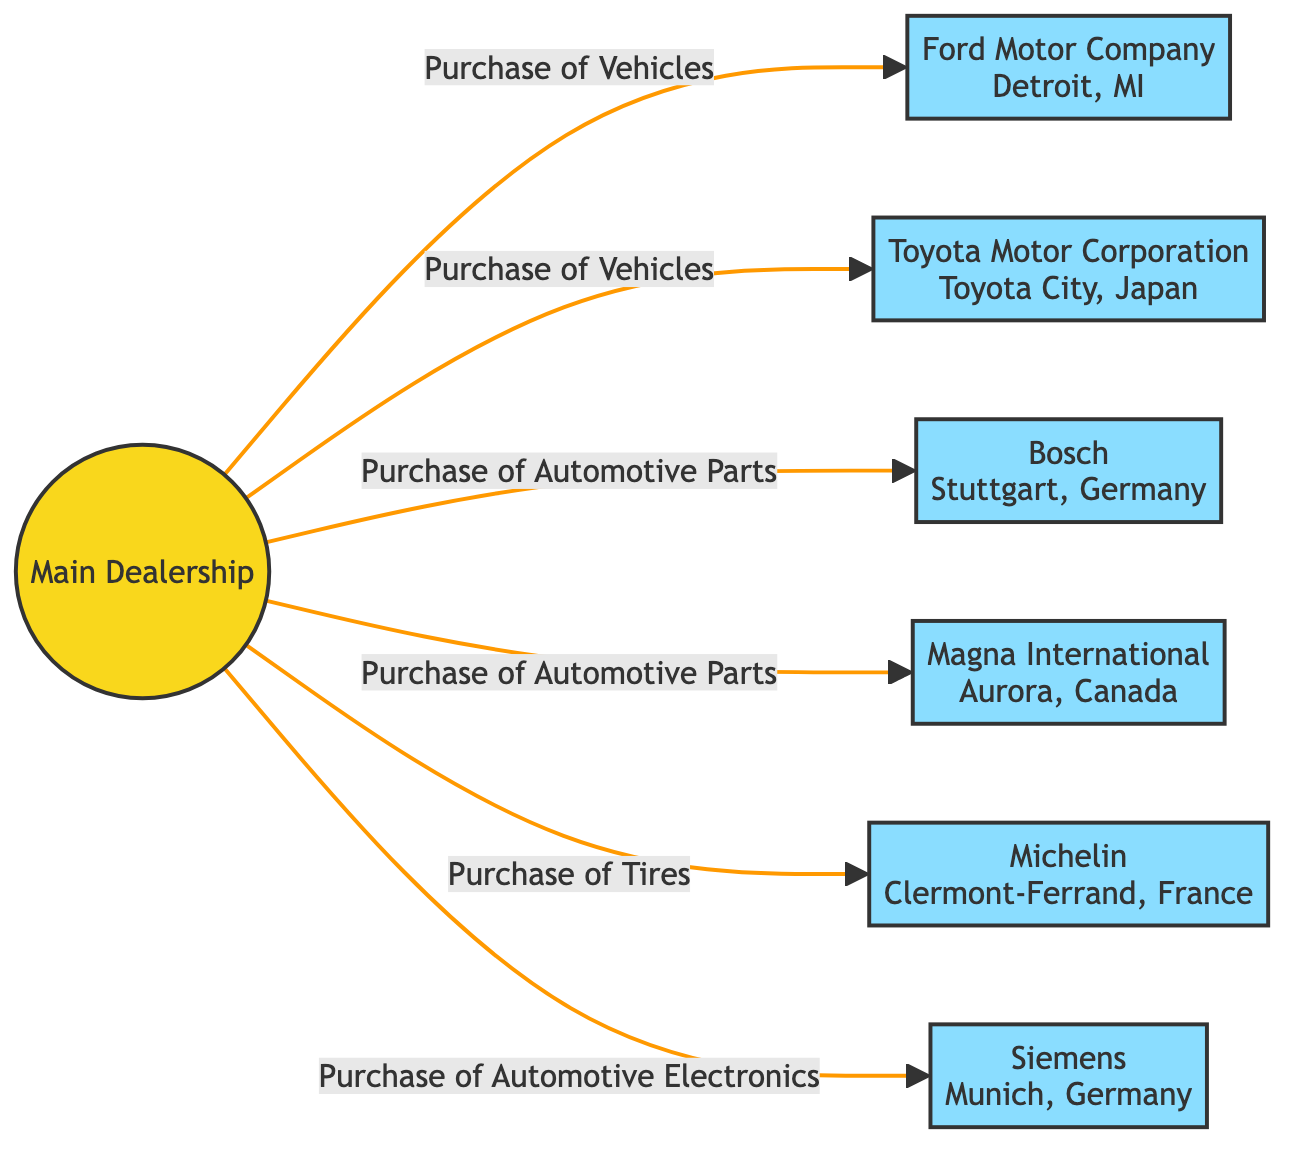What is the total number of suppliers shown in the diagram? The diagram lists six distinct suppliers connected to the main dealership. The suppliers are Ford Motor Company, Toyota Motor Corporation, Bosch, Magna International, Michelin, and Siemens.
Answer: 6 What relationship does the dealership have with Bosch? The relationship between the main dealership and Bosch is defined as "Purchase of Automotive Parts" according to the edges shown in the diagram.
Answer: Purchase of Automotive Parts Which supplier is located in Munich, Germany? The node designated as Siemens is listed in the diagram as being located in Munich, Germany.
Answer: Siemens How many different types of purchases does the dealership make? The dealership engages in three distinct types of purchases: vehicles from Ford and Toyota, automotive parts from Bosch and Magna, and tires from Michelin, plus automotive electronics from Siemens. This totals five unique purchase types.
Answer: 5 Which supplier has its headquarters in Clermont-Ferrand, France? The diagram shows Michelin as the supplier with its headquarters located in Clermont-Ferrand, France.
Answer: Michelin Which two suppliers offer vehicles to the dealership? The two suppliers that provide vehicles to the dealership are Ford Motor Company and Toyota Motor Corporation, as indicated by the relevant edges in the diagram.
Answer: Ford Motor Company, Toyota Motor Corporation What is the geographic location of Magna International? Magna International is identified in the diagram as being located in Aurora, Canada.
Answer: Aurora, Canada Which supplier offers automotive electronics to the dealership? The supplier that provides automotive electronics is Siemens, as stated in the relationship directed from the dealership to Siemens in the diagram.
Answer: Siemens What are the overall types of products purchased by the dealership? The dealership purchases vehicles, automotive parts, tires, and automotive electronics, each being classified under the types of purchases made from various suppliers in the diagram.
Answer: Vehicles, Automotive Parts, Tires, Automotive Electronics 